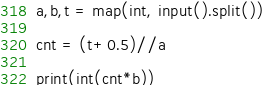Convert code to text. <code><loc_0><loc_0><loc_500><loc_500><_Python_>a,b,t = map(int, input().split())

cnt = (t+0.5)//a

print(int(cnt*b))</code> 